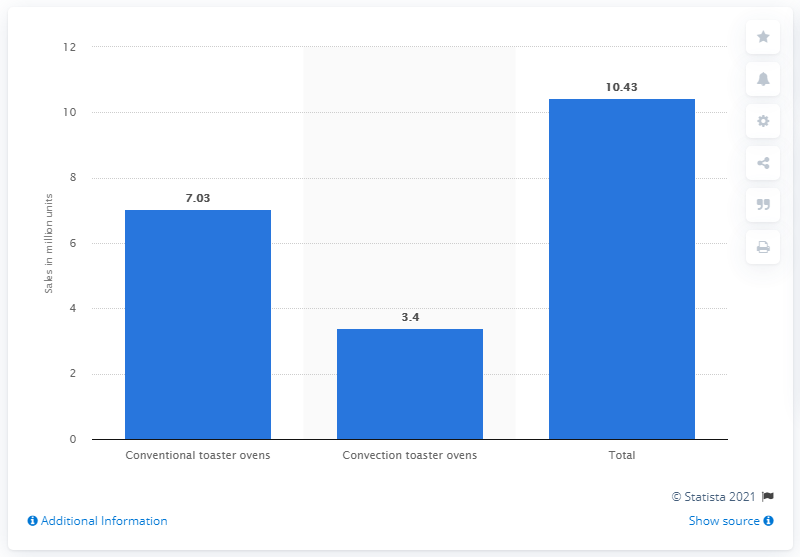Draw attention to some important aspects in this diagram. In 2010, a total of 3,400 convection toaster ovens were sold in the United States. 